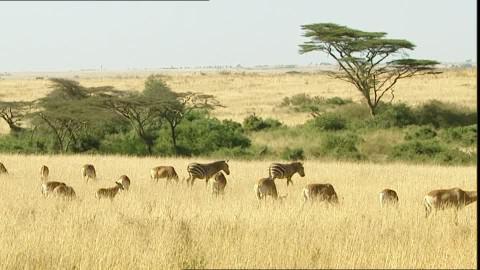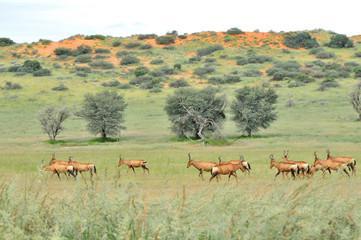The first image is the image on the left, the second image is the image on the right. Given the left and right images, does the statement "An image shows multiple similarly-posed gazelles with dark diagonal stripes across their bodies." hold true? Answer yes or no. No. 